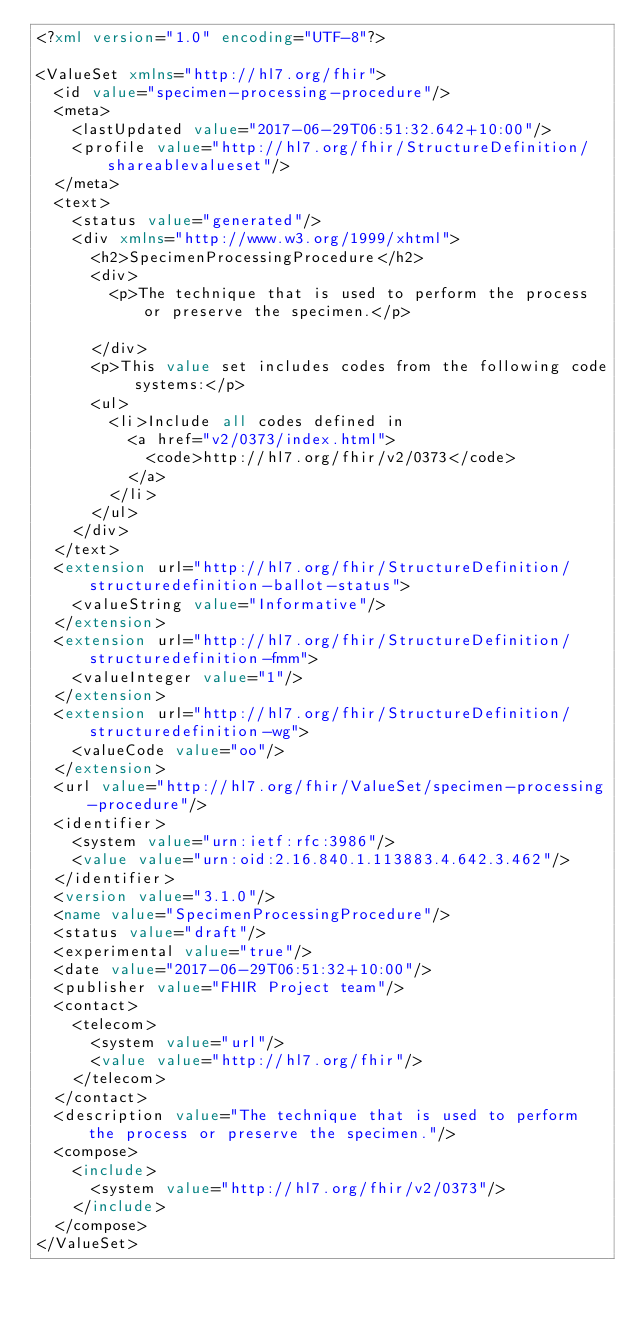Convert code to text. <code><loc_0><loc_0><loc_500><loc_500><_XML_><?xml version="1.0" encoding="UTF-8"?>

<ValueSet xmlns="http://hl7.org/fhir">
  <id value="specimen-processing-procedure"/>
  <meta>
    <lastUpdated value="2017-06-29T06:51:32.642+10:00"/>
    <profile value="http://hl7.org/fhir/StructureDefinition/shareablevalueset"/>
  </meta>
  <text>
    <status value="generated"/>
    <div xmlns="http://www.w3.org/1999/xhtml">
      <h2>SpecimenProcessingProcedure</h2>
      <div>
        <p>The technique that is used to perform the process or preserve the specimen.</p>

      </div>
      <p>This value set includes codes from the following code systems:</p>
      <ul>
        <li>Include all codes defined in 
          <a href="v2/0373/index.html">
            <code>http://hl7.org/fhir/v2/0373</code>
          </a>
        </li>
      </ul>
    </div>
  </text>
  <extension url="http://hl7.org/fhir/StructureDefinition/structuredefinition-ballot-status">
    <valueString value="Informative"/>
  </extension>
  <extension url="http://hl7.org/fhir/StructureDefinition/structuredefinition-fmm">
    <valueInteger value="1"/>
  </extension>
  <extension url="http://hl7.org/fhir/StructureDefinition/structuredefinition-wg">
    <valueCode value="oo"/>
  </extension>
  <url value="http://hl7.org/fhir/ValueSet/specimen-processing-procedure"/>
  <identifier>
    <system value="urn:ietf:rfc:3986"/>
    <value value="urn:oid:2.16.840.1.113883.4.642.3.462"/>
  </identifier>
  <version value="3.1.0"/>
  <name value="SpecimenProcessingProcedure"/>
  <status value="draft"/>
  <experimental value="true"/>
  <date value="2017-06-29T06:51:32+10:00"/>
  <publisher value="FHIR Project team"/>
  <contact>
    <telecom>
      <system value="url"/>
      <value value="http://hl7.org/fhir"/>
    </telecom>
  </contact>
  <description value="The technique that is used to perform the process or preserve the specimen."/>
  <compose>
    <include>
      <system value="http://hl7.org/fhir/v2/0373"/>
    </include>
  </compose>
</ValueSet></code> 